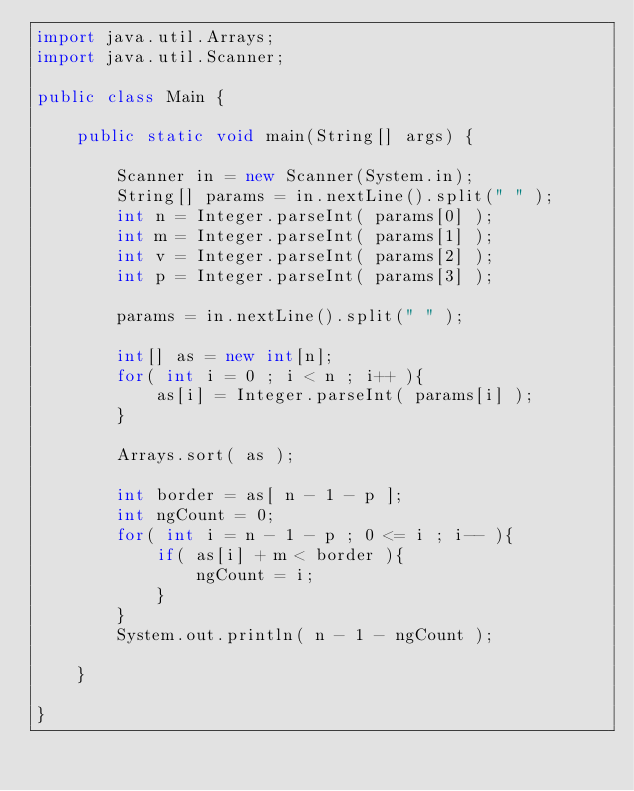<code> <loc_0><loc_0><loc_500><loc_500><_Java_>import java.util.Arrays;
import java.util.Scanner;

public class Main {

    public static void main(String[] args) {

        Scanner in = new Scanner(System.in);
        String[] params = in.nextLine().split(" " );
        int n = Integer.parseInt( params[0] );
        int m = Integer.parseInt( params[1] );
        int v = Integer.parseInt( params[2] );
        int p = Integer.parseInt( params[3] );

        params = in.nextLine().split(" " );

        int[] as = new int[n];
        for( int i = 0 ; i < n ; i++ ){
            as[i] = Integer.parseInt( params[i] );
        }

        Arrays.sort( as );

        int border = as[ n - 1 - p ];
        int ngCount = 0;
        for( int i = n - 1 - p ; 0 <= i ; i-- ){
            if( as[i] + m < border ){
                ngCount = i;
            }
        }
        System.out.println( n - 1 - ngCount );
        
    }

}

</code> 